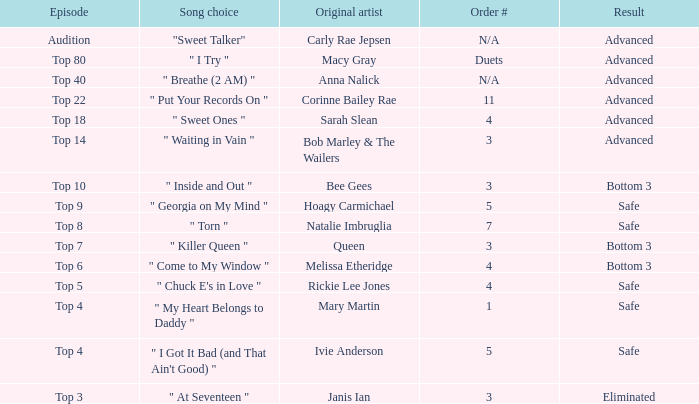What were the consequences of the top 3 episode? Eliminated. 